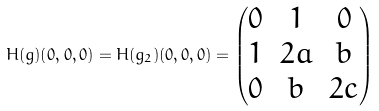Convert formula to latex. <formula><loc_0><loc_0><loc_500><loc_500>H ( g ) ( 0 , 0 , 0 ) = H ( g _ { 2 } ) ( 0 , 0 , 0 ) = \left ( \begin{matrix} 0 & 1 & 0 \\ 1 & 2 a & b \\ 0 & b & 2 c \end{matrix} \right )</formula> 